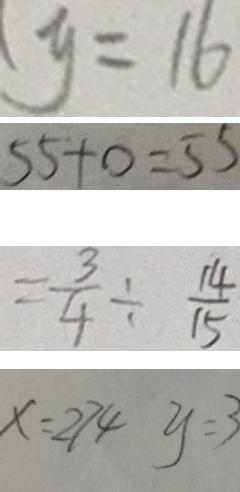Convert formula to latex. <formula><loc_0><loc_0><loc_500><loc_500>y = 1 6 
 5 5 + 0 = 5 5 
 = \frac { 3 } { 4 } \div \frac { 1 4 } { 1 5 } 
 x = 2 7 4 y = 3</formula> 